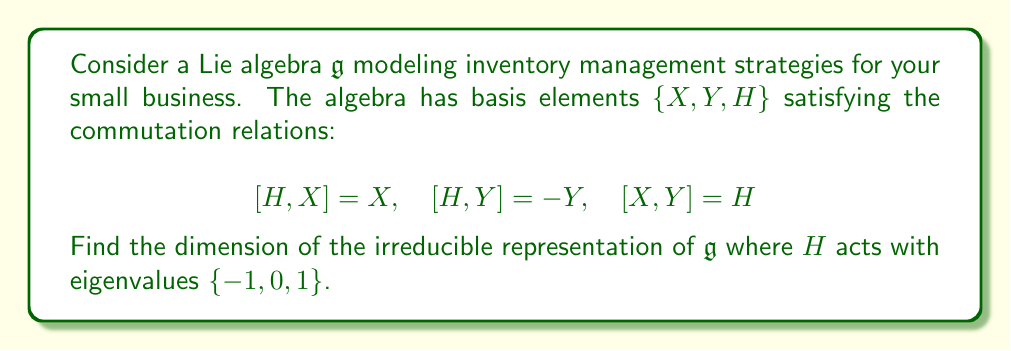Could you help me with this problem? 1) First, recognize that this Lie algebra is isomorphic to $\mathfrak{sl}(2,\mathbb{C})$, which models a simplified inventory management system.

2) In any finite-dimensional irreducible representation of $\mathfrak{sl}(2,\mathbb{C})$, the eigenvalues of $H$ form an arithmetic sequence with step 2.

3) Given the eigenvalues $\{-1, 0, 1\}$, we can deduce that this is a 3-dimensional representation.

4) Let's denote the eigenvectors as $v_{-1}, v_0, v_1$ corresponding to eigenvalues $-1, 0, 1$ respectively.

5) The action of $X$ and $Y$ on these vectors is:

   $X v_{-1} = v_0, \quad X v_0 = v_1, \quad X v_1 = 0$
   $Y v_1 = v_0, \quad Y v_0 = v_{-1}, \quad Y v_{-1} = 0$

6) This representation corresponds to optimizing three levels of inventory (low, medium, high), where $X$ represents increasing inventory and $Y$ represents decreasing inventory.

7) The dimension of this irreducible representation is 3, which matches the number of distinct eigenvalues of $H$.
Answer: 3 